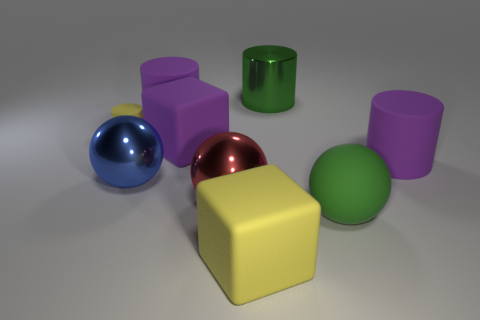What is the size of the rubber ball that is the same color as the shiny cylinder?
Ensure brevity in your answer.  Large. Are there more matte cylinders behind the yellow cylinder than big blue objects to the right of the blue ball?
Ensure brevity in your answer.  Yes. How many big green cylinders are in front of the large purple cylinder that is on the left side of the rubber sphere?
Your answer should be very brief. 0. There is a large block that is the same color as the tiny matte thing; what material is it?
Give a very brief answer. Rubber. How many other things are there of the same color as the large matte sphere?
Provide a short and direct response. 1. What color is the block on the left side of the rubber cube in front of the red shiny object?
Provide a short and direct response. Purple. Is there a large rubber cylinder that has the same color as the small thing?
Your answer should be compact. No. How many metallic things are either small blue objects or cubes?
Keep it short and to the point. 0. Is there a block that has the same material as the small yellow thing?
Keep it short and to the point. Yes. How many cylinders are both behind the tiny yellow matte thing and in front of the metal cylinder?
Offer a very short reply. 1. 